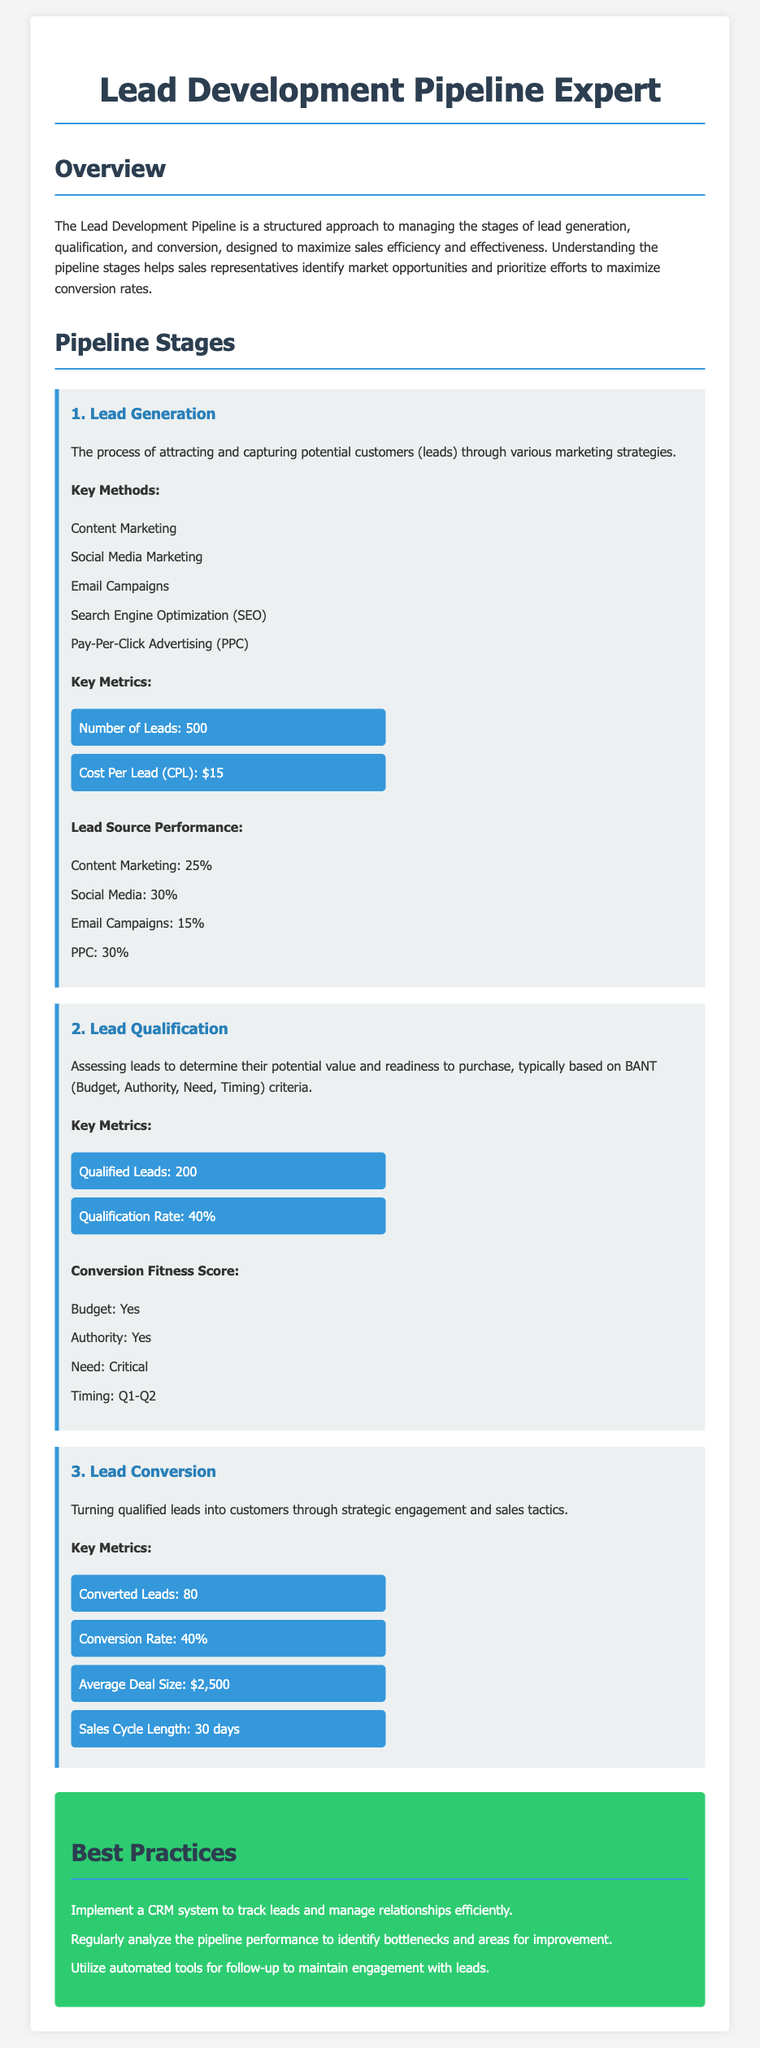What is the total number of leads generated? The total number of leads generated is stated in the 'Key Metrics' section of Lead Generation.
Answer: 500 What is the cost per lead? The cost per lead is indicated in the 'Key Metrics' section of Lead Generation.
Answer: $15 What is the qualification rate? The qualification rate is provided in the 'Key Metrics' section of Lead Qualification.
Answer: 40% How many converted leads are there? The number of converted leads is listed in the 'Key Metrics' section of Lead Conversion.
Answer: 80 What is the average deal size? The average deal size is mentioned in the 'Key Metrics' section of Lead Conversion.
Answer: $2,500 What is the sales cycle length? The sales cycle length can be found in the 'Key Metrics' section of Lead Conversion.
Answer: 30 days Which lead generation method has the highest performance? The lead generation method with the highest performance is identified in the 'Lead Source Performance' section.
Answer: Social Media What is a key practice suggested in the best practices section? A notable suggestion from the best practices section is included to enhance lead management.
Answer: Implement a CRM system 